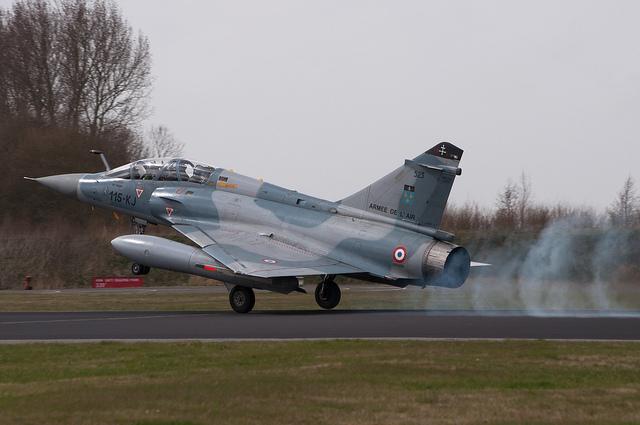Is this an army plane?
Write a very short answer. Yes. What is the plane doing?
Write a very short answer. Taking off. When was it built?
Write a very short answer. 2000. Is the jet moving?
Quick response, please. Yes. How many wheels are on the ground?
Be succinct. 2. Is the plane taking off?
Keep it brief. Yes. Is the jet taking off?
Short answer required. Yes. What color is the jet?
Short answer required. Gray. 